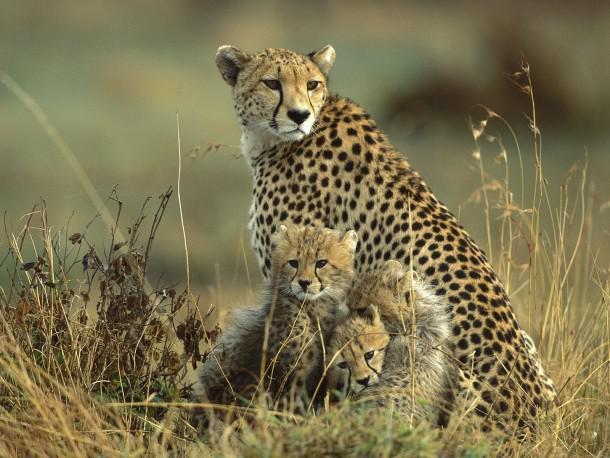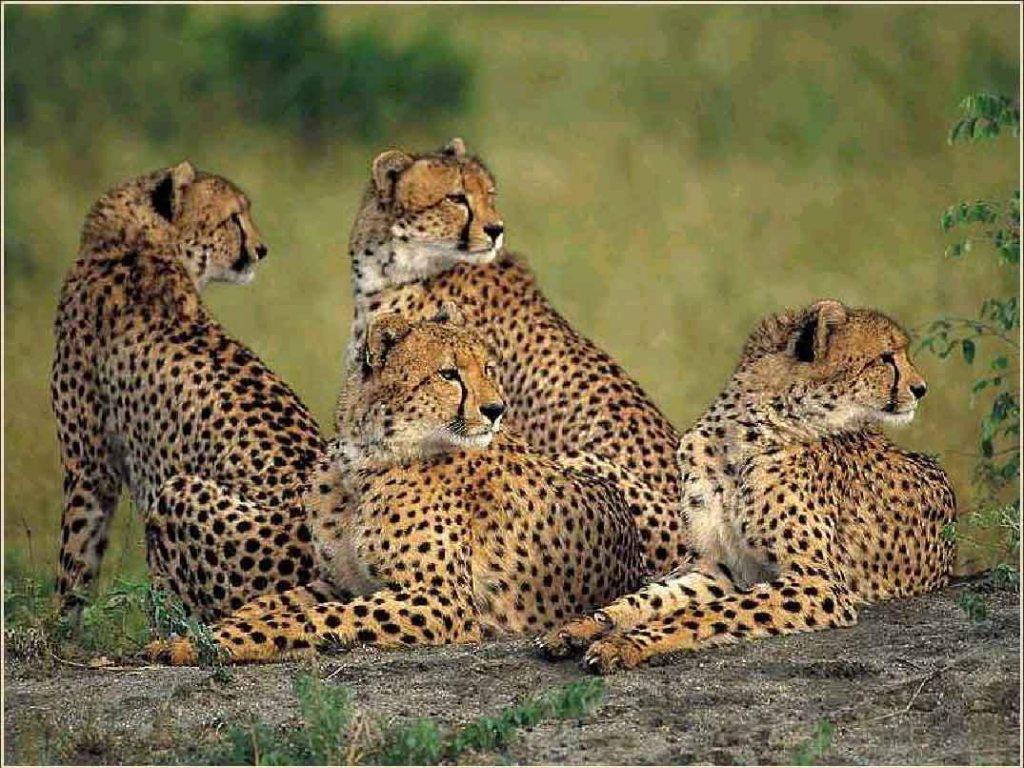The first image is the image on the left, the second image is the image on the right. For the images displayed, is the sentence "One of the images shows exactly two leopards." factually correct? Answer yes or no. No. 